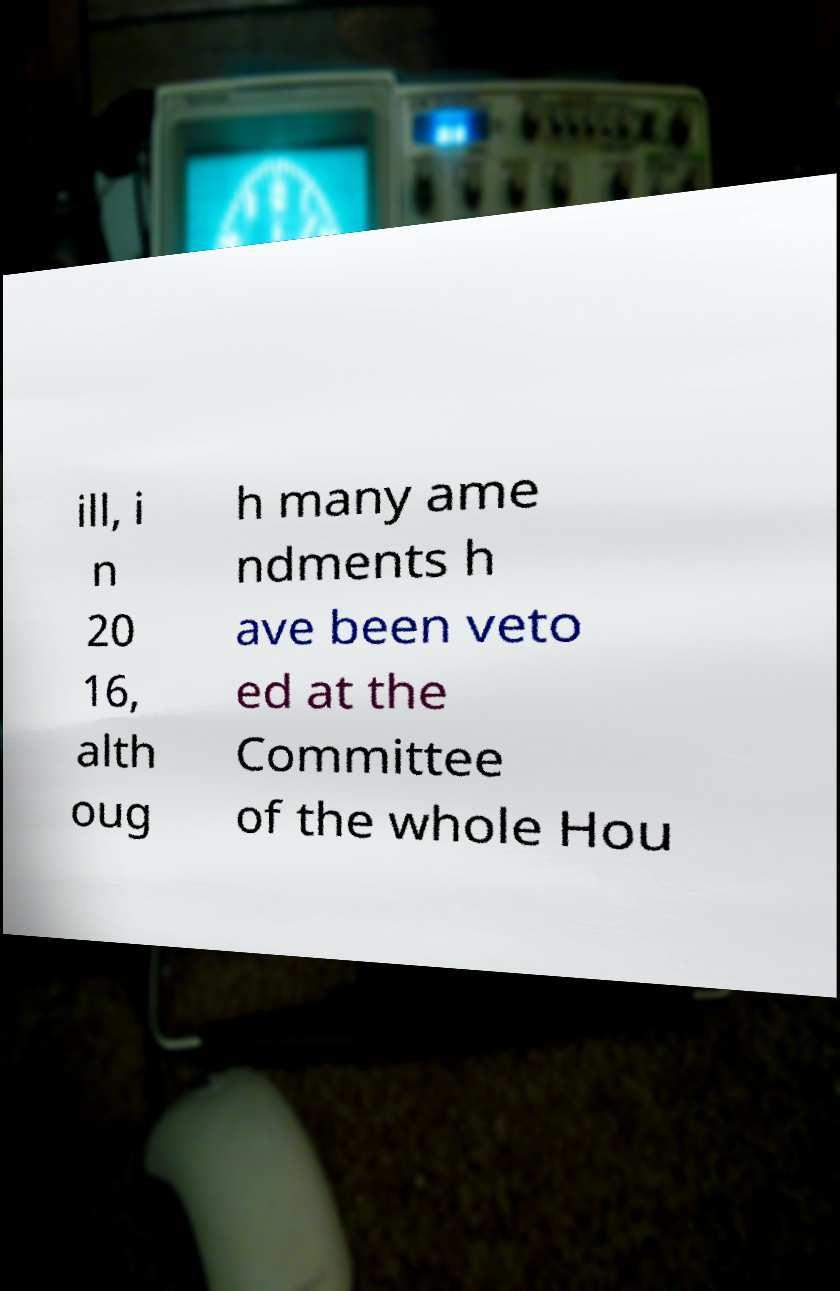Please read and relay the text visible in this image. What does it say? ill, i n 20 16, alth oug h many ame ndments h ave been veto ed at the Committee of the whole Hou 